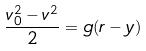<formula> <loc_0><loc_0><loc_500><loc_500>\frac { v _ { 0 } ^ { 2 } - v ^ { 2 } } { 2 } = g ( r - y )</formula> 